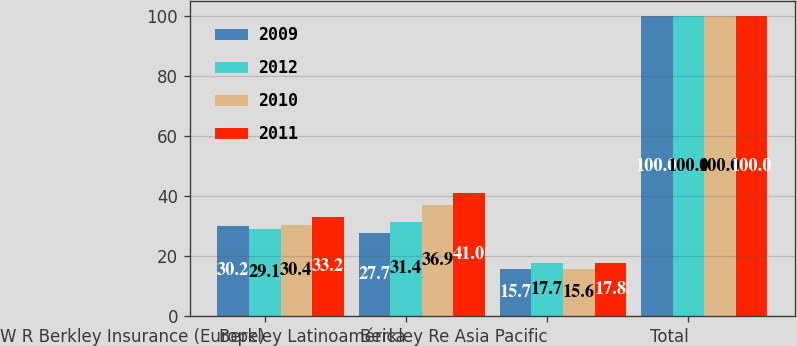Convert chart to OTSL. <chart><loc_0><loc_0><loc_500><loc_500><stacked_bar_chart><ecel><fcel>W R Berkley Insurance (Europe)<fcel>Berkley Latinoamérica<fcel>Berkley Re Asia Pacific<fcel>Total<nl><fcel>2009<fcel>30.2<fcel>27.7<fcel>15.7<fcel>100<nl><fcel>2012<fcel>29.1<fcel>31.4<fcel>17.7<fcel>100<nl><fcel>2010<fcel>30.4<fcel>36.9<fcel>15.6<fcel>100<nl><fcel>2011<fcel>33.2<fcel>41<fcel>17.8<fcel>100<nl></chart> 